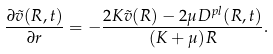<formula> <loc_0><loc_0><loc_500><loc_500>\frac { \partial \tilde { v } ( R , t ) } { \partial r } = - \frac { 2 K \tilde { v } ( R ) - 2 \mu D ^ { p l } ( R , t ) } { ( K + \mu ) R } .</formula> 